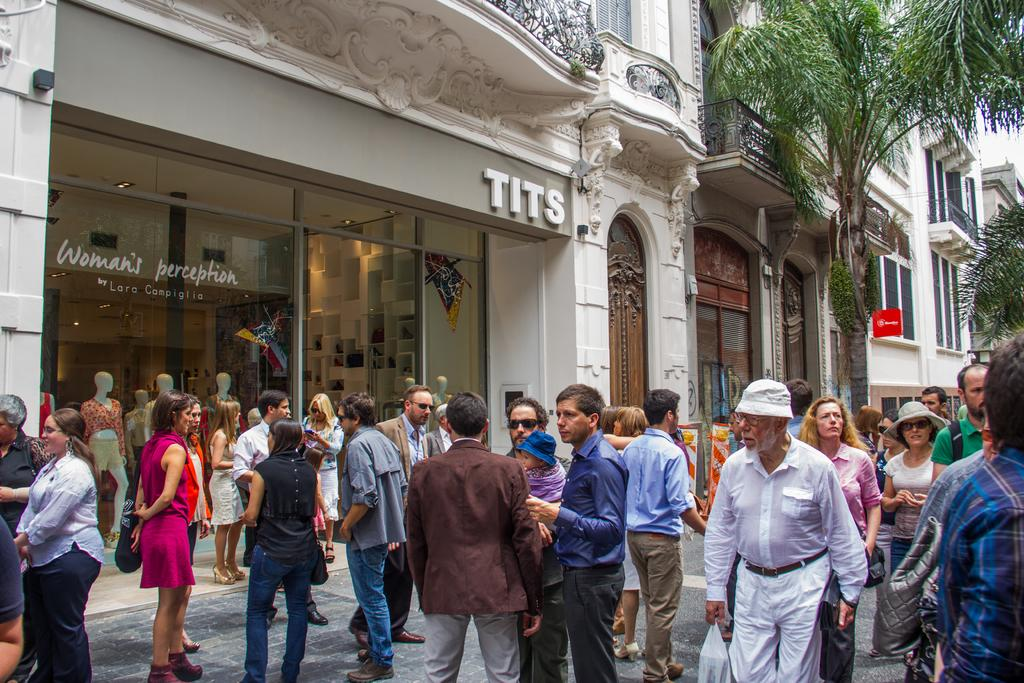Who is present in the image? There are people in the image. What are the people doing in the image? The people are doing different activities. What can be seen in the background of the image? There is a shop and trees in the background of the image. How many brothers are present in the image? There is no mention of brothers in the image, so we cannot determine the number of brothers present. 